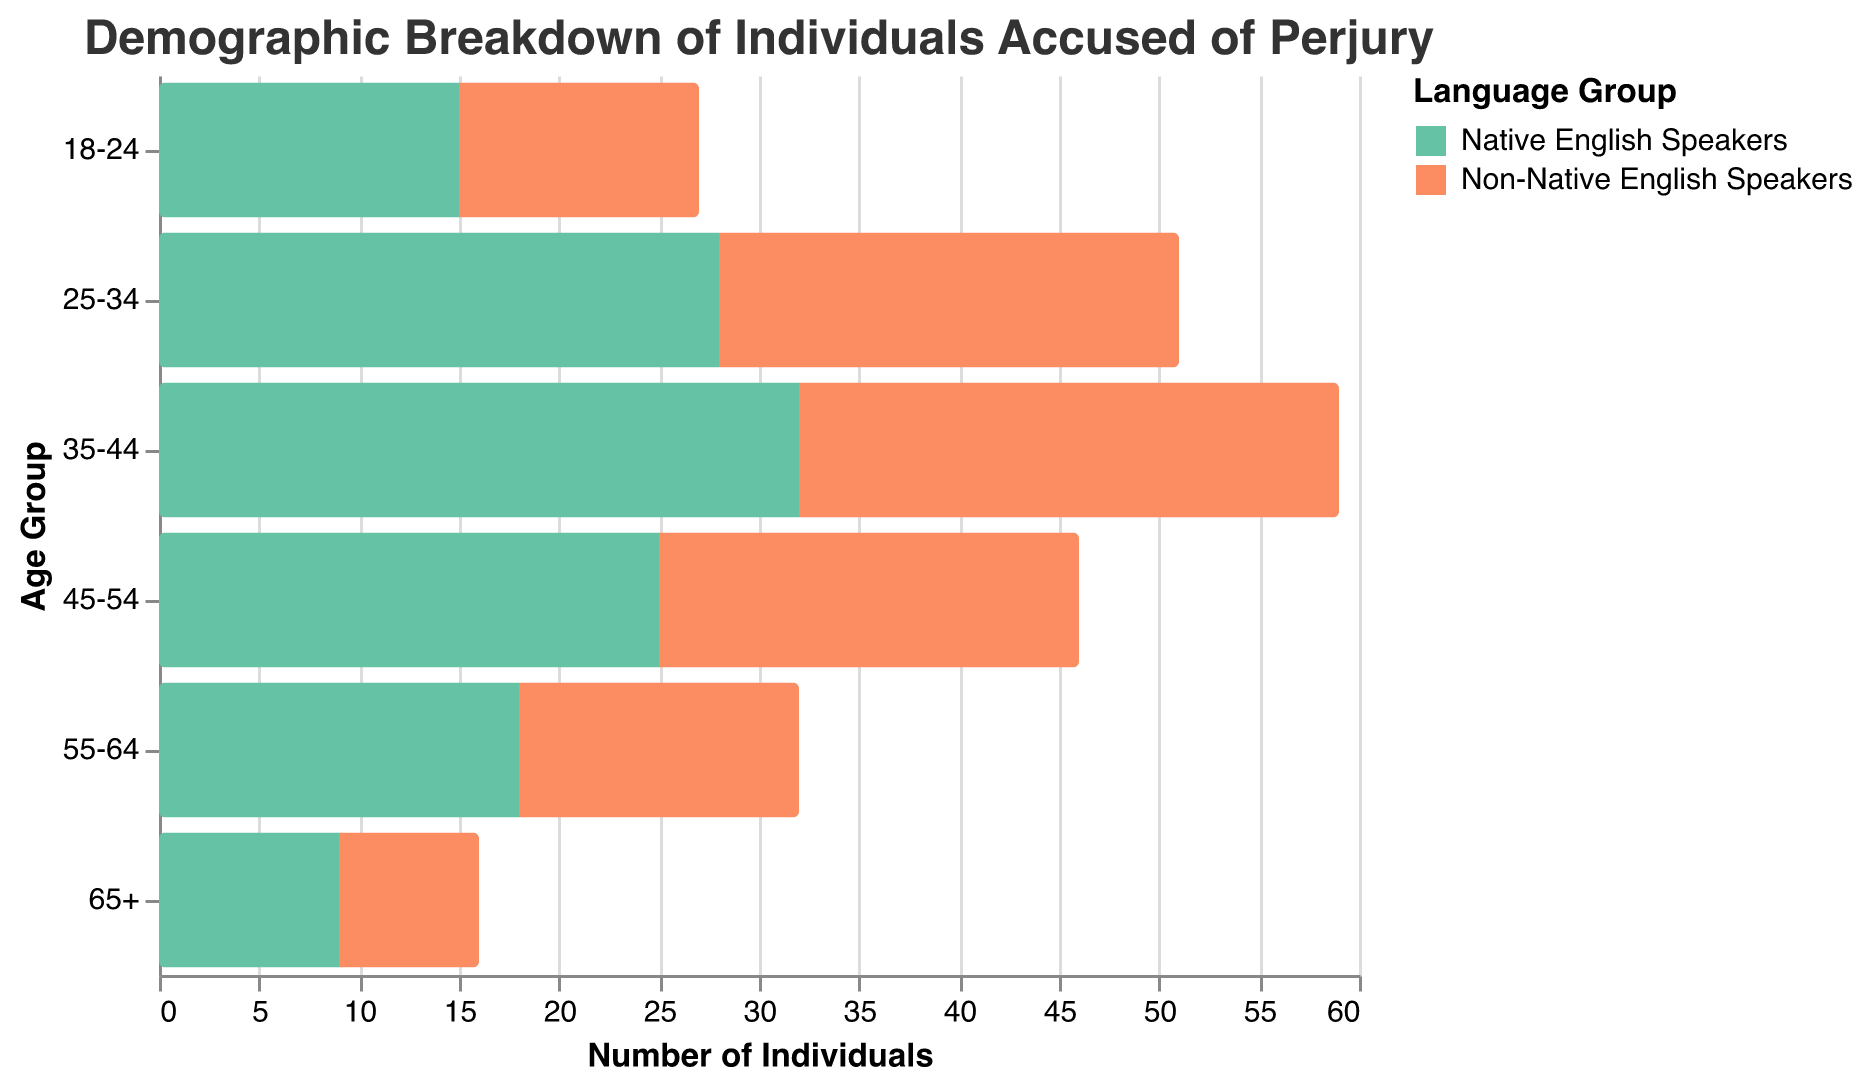What is the title of the figure? The title is located at the top of the figure.
Answer: Demographic Breakdown of Individuals Accused of Perjury Which age group has the highest count of Native English speakers accused of perjury? By checking the length of the bars for Native English speakers in each age group, the longest bar corresponds to the age group 35-44.
Answer: 35-44 How many Non-Native English speakers aged 25-34 were accused of perjury? The count for Non-Native English speakers in the 25-34 age group is given directly from the bar chart.
Answer: 23 Which age group has the least number of individuals accused of perjury for both Native and Non-Native English speakers? By comparing the lengths of all bars, the shortest bars for both groups correspond to the age group 65+.
Answer: 65+ Are there more individuals aged 45-54 accused of perjury among Native English speakers or Non-Native English speakers? By comparing the lengths of the respective bars for the age group 45-54, the Native English speakers have a longer bar than the Non-Native English speakers.
Answer: Native English speakers Calculate the difference between Native and Non-Native English speakers aged 35-44 accused of perjury. Native English speakers have a count of 32, and Non-Native English speakers have a count of 27. The difference is 32 - 27.
Answer: 5 Which language group has generally higher counts of individuals accused of perjury across all age groups? By observing the overall pattern, the Native English speakers have longer bars in all age groups compared to the Non-Native English speakers.
Answer: Native English speakers What is the total number of individuals accused of perjury in the 55-64 age group for both Native and Non-Native English speakers? Summing up the values for 55-64 age group: Native English speakers (18) + Non-Native English speakers (14).
Answer: 32 From the figure, what can we infer about the age distribution trend for individuals accused of perjury? By analyzing the bar lengths across age groups, both Native and Non-Native English speakers show a declining trend with increasing age.
Answer: Declines with age 